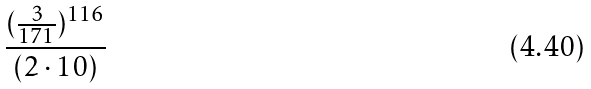Convert formula to latex. <formula><loc_0><loc_0><loc_500><loc_500>\frac { ( \frac { 3 } { 1 7 1 } ) ^ { 1 1 6 } } { ( 2 \cdot 1 0 ) }</formula> 